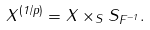<formula> <loc_0><loc_0><loc_500><loc_500>X ^ { ( 1 / p ) } = X \times _ { S } S _ { F ^ { - 1 } } .</formula> 